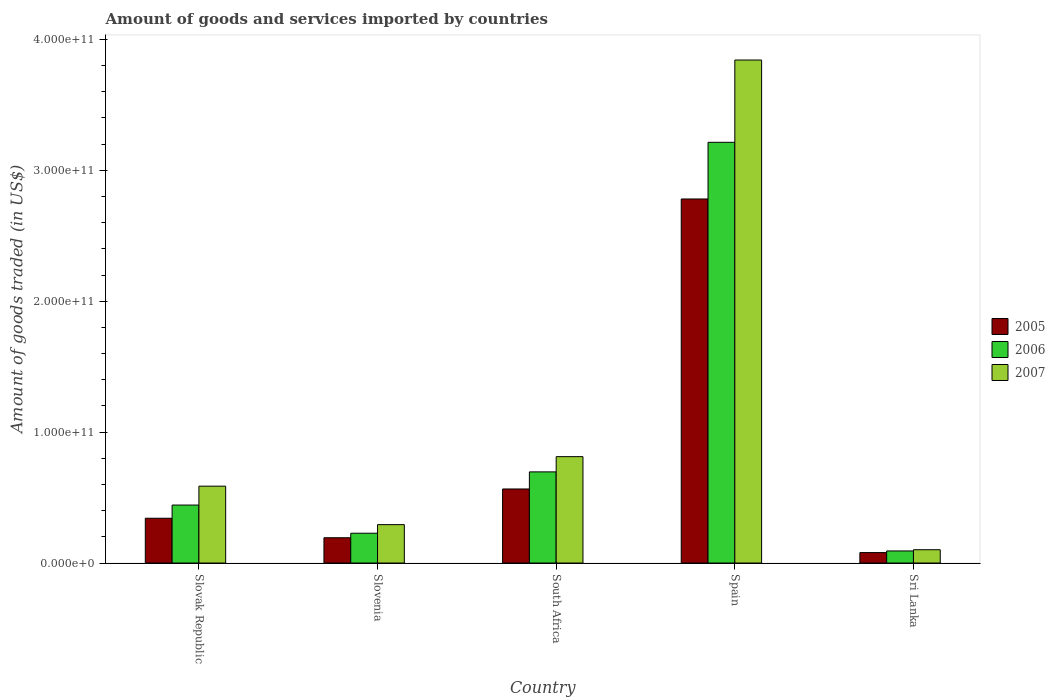How many bars are there on the 4th tick from the left?
Your answer should be very brief. 3. How many bars are there on the 5th tick from the right?
Ensure brevity in your answer.  3. What is the total amount of goods and services imported in 2006 in Slovak Republic?
Your answer should be compact. 4.43e+1. Across all countries, what is the maximum total amount of goods and services imported in 2006?
Offer a terse response. 3.21e+11. Across all countries, what is the minimum total amount of goods and services imported in 2006?
Your response must be concise. 9.23e+09. In which country was the total amount of goods and services imported in 2006 maximum?
Provide a short and direct response. Spain. In which country was the total amount of goods and services imported in 2005 minimum?
Offer a terse response. Sri Lanka. What is the total total amount of goods and services imported in 2006 in the graph?
Keep it short and to the point. 4.67e+11. What is the difference between the total amount of goods and services imported in 2007 in Slovak Republic and that in Slovenia?
Provide a succinct answer. 2.94e+1. What is the difference between the total amount of goods and services imported in 2007 in Slovak Republic and the total amount of goods and services imported in 2005 in Spain?
Your answer should be very brief. -2.19e+11. What is the average total amount of goods and services imported in 2005 per country?
Provide a short and direct response. 7.92e+1. What is the difference between the total amount of goods and services imported of/in 2007 and total amount of goods and services imported of/in 2006 in South Africa?
Offer a terse response. 1.16e+1. In how many countries, is the total amount of goods and services imported in 2006 greater than 340000000000 US$?
Offer a terse response. 0. What is the ratio of the total amount of goods and services imported in 2006 in South Africa to that in Spain?
Your answer should be very brief. 0.22. Is the difference between the total amount of goods and services imported in 2007 in Slovak Republic and Spain greater than the difference between the total amount of goods and services imported in 2006 in Slovak Republic and Spain?
Your answer should be very brief. No. What is the difference between the highest and the second highest total amount of goods and services imported in 2006?
Keep it short and to the point. 2.77e+11. What is the difference between the highest and the lowest total amount of goods and services imported in 2006?
Your response must be concise. 3.12e+11. What does the 2nd bar from the left in Sri Lanka represents?
Give a very brief answer. 2006. How many bars are there?
Provide a short and direct response. 15. How many countries are there in the graph?
Your response must be concise. 5. What is the difference between two consecutive major ticks on the Y-axis?
Give a very brief answer. 1.00e+11. Are the values on the major ticks of Y-axis written in scientific E-notation?
Your response must be concise. Yes. Does the graph contain any zero values?
Provide a short and direct response. No. Does the graph contain grids?
Make the answer very short. No. How are the legend labels stacked?
Ensure brevity in your answer.  Vertical. What is the title of the graph?
Make the answer very short. Amount of goods and services imported by countries. What is the label or title of the X-axis?
Give a very brief answer. Country. What is the label or title of the Y-axis?
Provide a short and direct response. Amount of goods traded (in US$). What is the Amount of goods traded (in US$) of 2005 in Slovak Republic?
Offer a very short reply. 3.42e+1. What is the Amount of goods traded (in US$) of 2006 in Slovak Republic?
Provide a short and direct response. 4.43e+1. What is the Amount of goods traded (in US$) in 2007 in Slovak Republic?
Give a very brief answer. 5.87e+1. What is the Amount of goods traded (in US$) in 2005 in Slovenia?
Provide a succinct answer. 1.93e+1. What is the Amount of goods traded (in US$) of 2006 in Slovenia?
Keep it short and to the point. 2.28e+1. What is the Amount of goods traded (in US$) in 2007 in Slovenia?
Your response must be concise. 2.93e+1. What is the Amount of goods traded (in US$) of 2005 in South Africa?
Offer a very short reply. 5.66e+1. What is the Amount of goods traded (in US$) of 2006 in South Africa?
Provide a short and direct response. 6.96e+1. What is the Amount of goods traded (in US$) of 2007 in South Africa?
Provide a succinct answer. 8.13e+1. What is the Amount of goods traded (in US$) in 2005 in Spain?
Provide a succinct answer. 2.78e+11. What is the Amount of goods traded (in US$) of 2006 in Spain?
Ensure brevity in your answer.  3.21e+11. What is the Amount of goods traded (in US$) in 2007 in Spain?
Provide a short and direct response. 3.84e+11. What is the Amount of goods traded (in US$) in 2005 in Sri Lanka?
Ensure brevity in your answer.  7.98e+09. What is the Amount of goods traded (in US$) in 2006 in Sri Lanka?
Offer a very short reply. 9.23e+09. What is the Amount of goods traded (in US$) in 2007 in Sri Lanka?
Provide a succinct answer. 1.02e+1. Across all countries, what is the maximum Amount of goods traded (in US$) of 2005?
Provide a short and direct response. 2.78e+11. Across all countries, what is the maximum Amount of goods traded (in US$) of 2006?
Your answer should be very brief. 3.21e+11. Across all countries, what is the maximum Amount of goods traded (in US$) in 2007?
Make the answer very short. 3.84e+11. Across all countries, what is the minimum Amount of goods traded (in US$) in 2005?
Your answer should be compact. 7.98e+09. Across all countries, what is the minimum Amount of goods traded (in US$) in 2006?
Keep it short and to the point. 9.23e+09. Across all countries, what is the minimum Amount of goods traded (in US$) of 2007?
Make the answer very short. 1.02e+1. What is the total Amount of goods traded (in US$) in 2005 in the graph?
Your answer should be very brief. 3.96e+11. What is the total Amount of goods traded (in US$) of 2006 in the graph?
Give a very brief answer. 4.67e+11. What is the total Amount of goods traded (in US$) in 2007 in the graph?
Provide a succinct answer. 5.64e+11. What is the difference between the Amount of goods traded (in US$) in 2005 in Slovak Republic and that in Slovenia?
Your answer should be compact. 1.49e+1. What is the difference between the Amount of goods traded (in US$) in 2006 in Slovak Republic and that in Slovenia?
Provide a short and direct response. 2.15e+1. What is the difference between the Amount of goods traded (in US$) in 2007 in Slovak Republic and that in Slovenia?
Offer a very short reply. 2.94e+1. What is the difference between the Amount of goods traded (in US$) in 2005 in Slovak Republic and that in South Africa?
Provide a succinct answer. -2.24e+1. What is the difference between the Amount of goods traded (in US$) of 2006 in Slovak Republic and that in South Africa?
Your answer should be very brief. -2.53e+1. What is the difference between the Amount of goods traded (in US$) in 2007 in Slovak Republic and that in South Africa?
Offer a terse response. -2.25e+1. What is the difference between the Amount of goods traded (in US$) in 2005 in Slovak Republic and that in Spain?
Offer a very short reply. -2.44e+11. What is the difference between the Amount of goods traded (in US$) in 2006 in Slovak Republic and that in Spain?
Give a very brief answer. -2.77e+11. What is the difference between the Amount of goods traded (in US$) in 2007 in Slovak Republic and that in Spain?
Offer a very short reply. -3.26e+11. What is the difference between the Amount of goods traded (in US$) of 2005 in Slovak Republic and that in Sri Lanka?
Provide a succinct answer. 2.62e+1. What is the difference between the Amount of goods traded (in US$) of 2006 in Slovak Republic and that in Sri Lanka?
Provide a succinct answer. 3.51e+1. What is the difference between the Amount of goods traded (in US$) of 2007 in Slovak Republic and that in Sri Lanka?
Your response must be concise. 4.85e+1. What is the difference between the Amount of goods traded (in US$) of 2005 in Slovenia and that in South Africa?
Your answer should be very brief. -3.72e+1. What is the difference between the Amount of goods traded (in US$) in 2006 in Slovenia and that in South Africa?
Provide a short and direct response. -4.69e+1. What is the difference between the Amount of goods traded (in US$) of 2007 in Slovenia and that in South Africa?
Your answer should be compact. -5.19e+1. What is the difference between the Amount of goods traded (in US$) in 2005 in Slovenia and that in Spain?
Provide a succinct answer. -2.59e+11. What is the difference between the Amount of goods traded (in US$) in 2006 in Slovenia and that in Spain?
Provide a succinct answer. -2.99e+11. What is the difference between the Amount of goods traded (in US$) of 2007 in Slovenia and that in Spain?
Your answer should be very brief. -3.55e+11. What is the difference between the Amount of goods traded (in US$) in 2005 in Slovenia and that in Sri Lanka?
Offer a very short reply. 1.13e+1. What is the difference between the Amount of goods traded (in US$) of 2006 in Slovenia and that in Sri Lanka?
Offer a terse response. 1.35e+1. What is the difference between the Amount of goods traded (in US$) of 2007 in Slovenia and that in Sri Lanka?
Offer a terse response. 1.92e+1. What is the difference between the Amount of goods traded (in US$) of 2005 in South Africa and that in Spain?
Provide a succinct answer. -2.22e+11. What is the difference between the Amount of goods traded (in US$) in 2006 in South Africa and that in Spain?
Give a very brief answer. -2.52e+11. What is the difference between the Amount of goods traded (in US$) in 2007 in South Africa and that in Spain?
Offer a terse response. -3.03e+11. What is the difference between the Amount of goods traded (in US$) of 2005 in South Africa and that in Sri Lanka?
Make the answer very short. 4.86e+1. What is the difference between the Amount of goods traded (in US$) in 2006 in South Africa and that in Sri Lanka?
Provide a short and direct response. 6.04e+1. What is the difference between the Amount of goods traded (in US$) in 2007 in South Africa and that in Sri Lanka?
Offer a terse response. 7.11e+1. What is the difference between the Amount of goods traded (in US$) of 2005 in Spain and that in Sri Lanka?
Your answer should be very brief. 2.70e+11. What is the difference between the Amount of goods traded (in US$) of 2006 in Spain and that in Sri Lanka?
Your response must be concise. 3.12e+11. What is the difference between the Amount of goods traded (in US$) in 2007 in Spain and that in Sri Lanka?
Ensure brevity in your answer.  3.74e+11. What is the difference between the Amount of goods traded (in US$) of 2005 in Slovak Republic and the Amount of goods traded (in US$) of 2006 in Slovenia?
Make the answer very short. 1.14e+1. What is the difference between the Amount of goods traded (in US$) of 2005 in Slovak Republic and the Amount of goods traded (in US$) of 2007 in Slovenia?
Keep it short and to the point. 4.88e+09. What is the difference between the Amount of goods traded (in US$) of 2006 in Slovak Republic and the Amount of goods traded (in US$) of 2007 in Slovenia?
Offer a very short reply. 1.50e+1. What is the difference between the Amount of goods traded (in US$) in 2005 in Slovak Republic and the Amount of goods traded (in US$) in 2006 in South Africa?
Your answer should be very brief. -3.54e+1. What is the difference between the Amount of goods traded (in US$) in 2005 in Slovak Republic and the Amount of goods traded (in US$) in 2007 in South Africa?
Make the answer very short. -4.70e+1. What is the difference between the Amount of goods traded (in US$) in 2006 in Slovak Republic and the Amount of goods traded (in US$) in 2007 in South Africa?
Give a very brief answer. -3.70e+1. What is the difference between the Amount of goods traded (in US$) in 2005 in Slovak Republic and the Amount of goods traded (in US$) in 2006 in Spain?
Make the answer very short. -2.87e+11. What is the difference between the Amount of goods traded (in US$) of 2005 in Slovak Republic and the Amount of goods traded (in US$) of 2007 in Spain?
Offer a terse response. -3.50e+11. What is the difference between the Amount of goods traded (in US$) of 2006 in Slovak Republic and the Amount of goods traded (in US$) of 2007 in Spain?
Offer a very short reply. -3.40e+11. What is the difference between the Amount of goods traded (in US$) of 2005 in Slovak Republic and the Amount of goods traded (in US$) of 2006 in Sri Lanka?
Offer a terse response. 2.50e+1. What is the difference between the Amount of goods traded (in US$) of 2005 in Slovak Republic and the Amount of goods traded (in US$) of 2007 in Sri Lanka?
Make the answer very short. 2.40e+1. What is the difference between the Amount of goods traded (in US$) of 2006 in Slovak Republic and the Amount of goods traded (in US$) of 2007 in Sri Lanka?
Offer a terse response. 3.41e+1. What is the difference between the Amount of goods traded (in US$) in 2005 in Slovenia and the Amount of goods traded (in US$) in 2006 in South Africa?
Keep it short and to the point. -5.03e+1. What is the difference between the Amount of goods traded (in US$) of 2005 in Slovenia and the Amount of goods traded (in US$) of 2007 in South Africa?
Make the answer very short. -6.19e+1. What is the difference between the Amount of goods traded (in US$) in 2006 in Slovenia and the Amount of goods traded (in US$) in 2007 in South Africa?
Your answer should be compact. -5.85e+1. What is the difference between the Amount of goods traded (in US$) in 2005 in Slovenia and the Amount of goods traded (in US$) in 2006 in Spain?
Your response must be concise. -3.02e+11. What is the difference between the Amount of goods traded (in US$) in 2005 in Slovenia and the Amount of goods traded (in US$) in 2007 in Spain?
Make the answer very short. -3.65e+11. What is the difference between the Amount of goods traded (in US$) in 2006 in Slovenia and the Amount of goods traded (in US$) in 2007 in Spain?
Offer a very short reply. -3.61e+11. What is the difference between the Amount of goods traded (in US$) in 2005 in Slovenia and the Amount of goods traded (in US$) in 2006 in Sri Lanka?
Keep it short and to the point. 1.01e+1. What is the difference between the Amount of goods traded (in US$) of 2005 in Slovenia and the Amount of goods traded (in US$) of 2007 in Sri Lanka?
Give a very brief answer. 9.16e+09. What is the difference between the Amount of goods traded (in US$) in 2006 in Slovenia and the Amount of goods traded (in US$) in 2007 in Sri Lanka?
Keep it short and to the point. 1.26e+1. What is the difference between the Amount of goods traded (in US$) in 2005 in South Africa and the Amount of goods traded (in US$) in 2006 in Spain?
Your answer should be compact. -2.65e+11. What is the difference between the Amount of goods traded (in US$) of 2005 in South Africa and the Amount of goods traded (in US$) of 2007 in Spain?
Keep it short and to the point. -3.28e+11. What is the difference between the Amount of goods traded (in US$) in 2006 in South Africa and the Amount of goods traded (in US$) in 2007 in Spain?
Your answer should be very brief. -3.15e+11. What is the difference between the Amount of goods traded (in US$) of 2005 in South Africa and the Amount of goods traded (in US$) of 2006 in Sri Lanka?
Your answer should be very brief. 4.73e+1. What is the difference between the Amount of goods traded (in US$) of 2005 in South Africa and the Amount of goods traded (in US$) of 2007 in Sri Lanka?
Provide a short and direct response. 4.64e+1. What is the difference between the Amount of goods traded (in US$) in 2006 in South Africa and the Amount of goods traded (in US$) in 2007 in Sri Lanka?
Provide a short and direct response. 5.95e+1. What is the difference between the Amount of goods traded (in US$) of 2005 in Spain and the Amount of goods traded (in US$) of 2006 in Sri Lanka?
Keep it short and to the point. 2.69e+11. What is the difference between the Amount of goods traded (in US$) in 2005 in Spain and the Amount of goods traded (in US$) in 2007 in Sri Lanka?
Provide a short and direct response. 2.68e+11. What is the difference between the Amount of goods traded (in US$) in 2006 in Spain and the Amount of goods traded (in US$) in 2007 in Sri Lanka?
Offer a terse response. 3.11e+11. What is the average Amount of goods traded (in US$) in 2005 per country?
Provide a short and direct response. 7.92e+1. What is the average Amount of goods traded (in US$) of 2006 per country?
Your answer should be compact. 9.35e+1. What is the average Amount of goods traded (in US$) of 2007 per country?
Ensure brevity in your answer.  1.13e+11. What is the difference between the Amount of goods traded (in US$) of 2005 and Amount of goods traded (in US$) of 2006 in Slovak Republic?
Give a very brief answer. -1.01e+1. What is the difference between the Amount of goods traded (in US$) in 2005 and Amount of goods traded (in US$) in 2007 in Slovak Republic?
Provide a short and direct response. -2.45e+1. What is the difference between the Amount of goods traded (in US$) in 2006 and Amount of goods traded (in US$) in 2007 in Slovak Republic?
Provide a short and direct response. -1.44e+1. What is the difference between the Amount of goods traded (in US$) in 2005 and Amount of goods traded (in US$) in 2006 in Slovenia?
Your answer should be very brief. -3.45e+09. What is the difference between the Amount of goods traded (in US$) in 2005 and Amount of goods traded (in US$) in 2007 in Slovenia?
Offer a very short reply. -1.00e+1. What is the difference between the Amount of goods traded (in US$) in 2006 and Amount of goods traded (in US$) in 2007 in Slovenia?
Make the answer very short. -6.56e+09. What is the difference between the Amount of goods traded (in US$) of 2005 and Amount of goods traded (in US$) of 2006 in South Africa?
Offer a very short reply. -1.31e+1. What is the difference between the Amount of goods traded (in US$) in 2005 and Amount of goods traded (in US$) in 2007 in South Africa?
Provide a succinct answer. -2.47e+1. What is the difference between the Amount of goods traded (in US$) in 2006 and Amount of goods traded (in US$) in 2007 in South Africa?
Keep it short and to the point. -1.16e+1. What is the difference between the Amount of goods traded (in US$) of 2005 and Amount of goods traded (in US$) of 2006 in Spain?
Keep it short and to the point. -4.33e+1. What is the difference between the Amount of goods traded (in US$) in 2005 and Amount of goods traded (in US$) in 2007 in Spain?
Offer a very short reply. -1.06e+11. What is the difference between the Amount of goods traded (in US$) in 2006 and Amount of goods traded (in US$) in 2007 in Spain?
Ensure brevity in your answer.  -6.29e+1. What is the difference between the Amount of goods traded (in US$) of 2005 and Amount of goods traded (in US$) of 2006 in Sri Lanka?
Keep it short and to the point. -1.25e+09. What is the difference between the Amount of goods traded (in US$) of 2005 and Amount of goods traded (in US$) of 2007 in Sri Lanka?
Keep it short and to the point. -2.19e+09. What is the difference between the Amount of goods traded (in US$) of 2006 and Amount of goods traded (in US$) of 2007 in Sri Lanka?
Your answer should be very brief. -9.39e+08. What is the ratio of the Amount of goods traded (in US$) of 2005 in Slovak Republic to that in Slovenia?
Provide a short and direct response. 1.77. What is the ratio of the Amount of goods traded (in US$) in 2006 in Slovak Republic to that in Slovenia?
Your answer should be compact. 1.94. What is the ratio of the Amount of goods traded (in US$) of 2007 in Slovak Republic to that in Slovenia?
Ensure brevity in your answer.  2. What is the ratio of the Amount of goods traded (in US$) of 2005 in Slovak Republic to that in South Africa?
Provide a succinct answer. 0.6. What is the ratio of the Amount of goods traded (in US$) in 2006 in Slovak Republic to that in South Africa?
Your response must be concise. 0.64. What is the ratio of the Amount of goods traded (in US$) of 2007 in Slovak Republic to that in South Africa?
Ensure brevity in your answer.  0.72. What is the ratio of the Amount of goods traded (in US$) in 2005 in Slovak Republic to that in Spain?
Provide a short and direct response. 0.12. What is the ratio of the Amount of goods traded (in US$) of 2006 in Slovak Republic to that in Spain?
Give a very brief answer. 0.14. What is the ratio of the Amount of goods traded (in US$) of 2007 in Slovak Republic to that in Spain?
Make the answer very short. 0.15. What is the ratio of the Amount of goods traded (in US$) in 2005 in Slovak Republic to that in Sri Lanka?
Offer a very short reply. 4.29. What is the ratio of the Amount of goods traded (in US$) in 2006 in Slovak Republic to that in Sri Lanka?
Your answer should be compact. 4.8. What is the ratio of the Amount of goods traded (in US$) in 2007 in Slovak Republic to that in Sri Lanka?
Provide a short and direct response. 5.78. What is the ratio of the Amount of goods traded (in US$) of 2005 in Slovenia to that in South Africa?
Your answer should be compact. 0.34. What is the ratio of the Amount of goods traded (in US$) in 2006 in Slovenia to that in South Africa?
Your answer should be compact. 0.33. What is the ratio of the Amount of goods traded (in US$) in 2007 in Slovenia to that in South Africa?
Ensure brevity in your answer.  0.36. What is the ratio of the Amount of goods traded (in US$) of 2005 in Slovenia to that in Spain?
Ensure brevity in your answer.  0.07. What is the ratio of the Amount of goods traded (in US$) in 2006 in Slovenia to that in Spain?
Keep it short and to the point. 0.07. What is the ratio of the Amount of goods traded (in US$) in 2007 in Slovenia to that in Spain?
Provide a succinct answer. 0.08. What is the ratio of the Amount of goods traded (in US$) in 2005 in Slovenia to that in Sri Lanka?
Offer a very short reply. 2.42. What is the ratio of the Amount of goods traded (in US$) in 2006 in Slovenia to that in Sri Lanka?
Make the answer very short. 2.47. What is the ratio of the Amount of goods traded (in US$) of 2007 in Slovenia to that in Sri Lanka?
Make the answer very short. 2.88. What is the ratio of the Amount of goods traded (in US$) in 2005 in South Africa to that in Spain?
Provide a short and direct response. 0.2. What is the ratio of the Amount of goods traded (in US$) in 2006 in South Africa to that in Spain?
Offer a terse response. 0.22. What is the ratio of the Amount of goods traded (in US$) in 2007 in South Africa to that in Spain?
Offer a terse response. 0.21. What is the ratio of the Amount of goods traded (in US$) in 2005 in South Africa to that in Sri Lanka?
Your answer should be compact. 7.09. What is the ratio of the Amount of goods traded (in US$) of 2006 in South Africa to that in Sri Lanka?
Your answer should be very brief. 7.55. What is the ratio of the Amount of goods traded (in US$) of 2007 in South Africa to that in Sri Lanka?
Your answer should be very brief. 7.99. What is the ratio of the Amount of goods traded (in US$) in 2005 in Spain to that in Sri Lanka?
Ensure brevity in your answer.  34.86. What is the ratio of the Amount of goods traded (in US$) of 2006 in Spain to that in Sri Lanka?
Your answer should be compact. 34.83. What is the ratio of the Amount of goods traded (in US$) in 2007 in Spain to that in Sri Lanka?
Ensure brevity in your answer.  37.79. What is the difference between the highest and the second highest Amount of goods traded (in US$) in 2005?
Give a very brief answer. 2.22e+11. What is the difference between the highest and the second highest Amount of goods traded (in US$) in 2006?
Provide a short and direct response. 2.52e+11. What is the difference between the highest and the second highest Amount of goods traded (in US$) of 2007?
Make the answer very short. 3.03e+11. What is the difference between the highest and the lowest Amount of goods traded (in US$) in 2005?
Offer a terse response. 2.70e+11. What is the difference between the highest and the lowest Amount of goods traded (in US$) of 2006?
Keep it short and to the point. 3.12e+11. What is the difference between the highest and the lowest Amount of goods traded (in US$) of 2007?
Your answer should be very brief. 3.74e+11. 